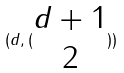Convert formula to latex. <formula><loc_0><loc_0><loc_500><loc_500>( d , ( \begin{matrix} d + 1 \\ 2 \end{matrix} ) )</formula> 